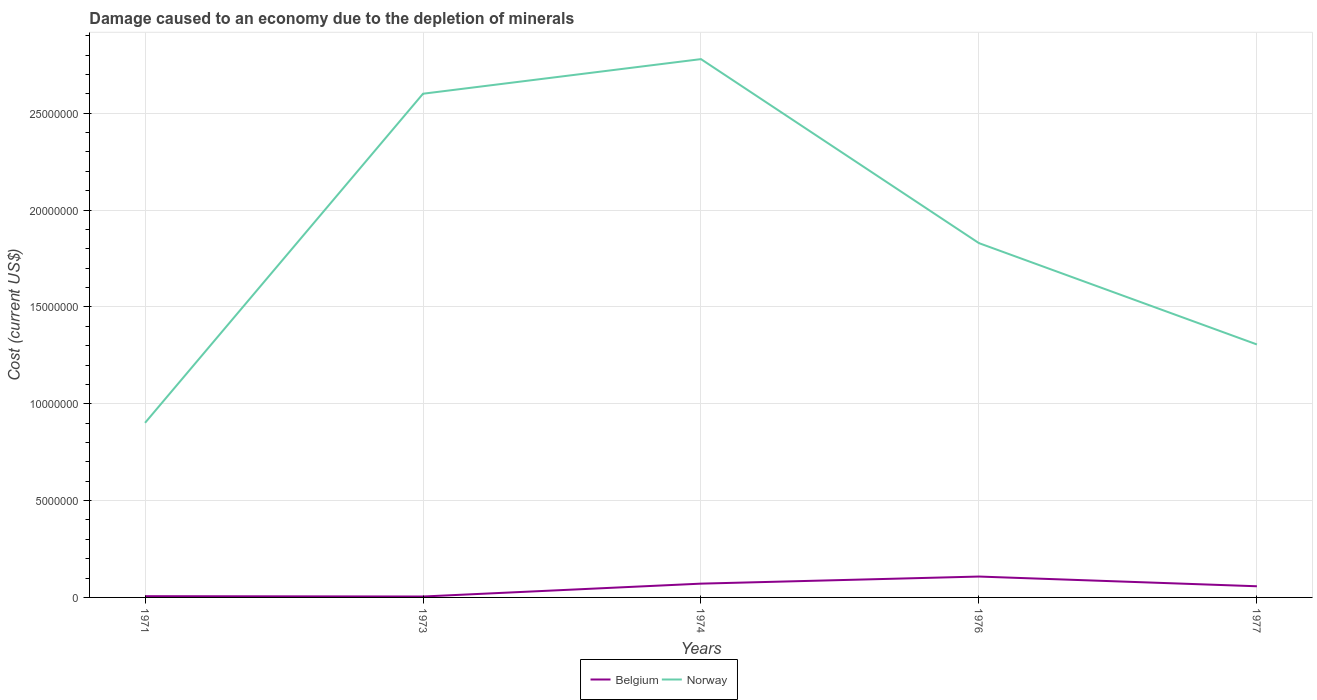How many different coloured lines are there?
Offer a very short reply. 2. Across all years, what is the maximum cost of damage caused due to the depletion of minerals in Belgium?
Ensure brevity in your answer.  4.70e+04. What is the total cost of damage caused due to the depletion of minerals in Belgium in the graph?
Keep it short and to the point. -5.29e+05. What is the difference between the highest and the second highest cost of damage caused due to the depletion of minerals in Norway?
Give a very brief answer. 1.88e+07. What is the difference between the highest and the lowest cost of damage caused due to the depletion of minerals in Belgium?
Provide a short and direct response. 3. How many years are there in the graph?
Your answer should be very brief. 5. What is the difference between two consecutive major ticks on the Y-axis?
Offer a terse response. 5.00e+06. Are the values on the major ticks of Y-axis written in scientific E-notation?
Your response must be concise. No. Does the graph contain grids?
Ensure brevity in your answer.  Yes. How are the legend labels stacked?
Offer a terse response. Horizontal. What is the title of the graph?
Make the answer very short. Damage caused to an economy due to the depletion of minerals. What is the label or title of the Y-axis?
Your response must be concise. Cost (current US$). What is the Cost (current US$) of Belgium in 1971?
Provide a short and direct response. 6.47e+04. What is the Cost (current US$) of Norway in 1971?
Your answer should be compact. 9.01e+06. What is the Cost (current US$) of Belgium in 1973?
Your response must be concise. 4.70e+04. What is the Cost (current US$) in Norway in 1973?
Provide a short and direct response. 2.60e+07. What is the Cost (current US$) in Belgium in 1974?
Provide a succinct answer. 7.12e+05. What is the Cost (current US$) in Norway in 1974?
Keep it short and to the point. 2.78e+07. What is the Cost (current US$) in Belgium in 1976?
Provide a short and direct response. 1.08e+06. What is the Cost (current US$) of Norway in 1976?
Provide a short and direct response. 1.83e+07. What is the Cost (current US$) in Belgium in 1977?
Keep it short and to the point. 5.77e+05. What is the Cost (current US$) in Norway in 1977?
Your response must be concise. 1.31e+07. Across all years, what is the maximum Cost (current US$) in Belgium?
Give a very brief answer. 1.08e+06. Across all years, what is the maximum Cost (current US$) in Norway?
Make the answer very short. 2.78e+07. Across all years, what is the minimum Cost (current US$) of Belgium?
Keep it short and to the point. 4.70e+04. Across all years, what is the minimum Cost (current US$) in Norway?
Ensure brevity in your answer.  9.01e+06. What is the total Cost (current US$) of Belgium in the graph?
Give a very brief answer. 2.48e+06. What is the total Cost (current US$) in Norway in the graph?
Give a very brief answer. 9.42e+07. What is the difference between the Cost (current US$) of Belgium in 1971 and that in 1973?
Offer a very short reply. 1.76e+04. What is the difference between the Cost (current US$) of Norway in 1971 and that in 1973?
Provide a short and direct response. -1.70e+07. What is the difference between the Cost (current US$) of Belgium in 1971 and that in 1974?
Provide a succinct answer. -6.47e+05. What is the difference between the Cost (current US$) of Norway in 1971 and that in 1974?
Your answer should be very brief. -1.88e+07. What is the difference between the Cost (current US$) in Belgium in 1971 and that in 1976?
Keep it short and to the point. -1.01e+06. What is the difference between the Cost (current US$) in Norway in 1971 and that in 1976?
Your response must be concise. -9.28e+06. What is the difference between the Cost (current US$) in Belgium in 1971 and that in 1977?
Offer a very short reply. -5.12e+05. What is the difference between the Cost (current US$) of Norway in 1971 and that in 1977?
Offer a terse response. -4.05e+06. What is the difference between the Cost (current US$) of Belgium in 1973 and that in 1974?
Provide a short and direct response. -6.65e+05. What is the difference between the Cost (current US$) of Norway in 1973 and that in 1974?
Make the answer very short. -1.79e+06. What is the difference between the Cost (current US$) of Belgium in 1973 and that in 1976?
Your response must be concise. -1.03e+06. What is the difference between the Cost (current US$) in Norway in 1973 and that in 1976?
Give a very brief answer. 7.71e+06. What is the difference between the Cost (current US$) in Belgium in 1973 and that in 1977?
Keep it short and to the point. -5.29e+05. What is the difference between the Cost (current US$) in Norway in 1973 and that in 1977?
Your response must be concise. 1.29e+07. What is the difference between the Cost (current US$) of Belgium in 1974 and that in 1976?
Your answer should be compact. -3.66e+05. What is the difference between the Cost (current US$) in Norway in 1974 and that in 1976?
Provide a succinct answer. 9.50e+06. What is the difference between the Cost (current US$) of Belgium in 1974 and that in 1977?
Offer a terse response. 1.36e+05. What is the difference between the Cost (current US$) in Norway in 1974 and that in 1977?
Your answer should be very brief. 1.47e+07. What is the difference between the Cost (current US$) in Belgium in 1976 and that in 1977?
Your answer should be compact. 5.01e+05. What is the difference between the Cost (current US$) in Norway in 1976 and that in 1977?
Your response must be concise. 5.23e+06. What is the difference between the Cost (current US$) of Belgium in 1971 and the Cost (current US$) of Norway in 1973?
Give a very brief answer. -2.59e+07. What is the difference between the Cost (current US$) in Belgium in 1971 and the Cost (current US$) in Norway in 1974?
Provide a succinct answer. -2.77e+07. What is the difference between the Cost (current US$) in Belgium in 1971 and the Cost (current US$) in Norway in 1976?
Make the answer very short. -1.82e+07. What is the difference between the Cost (current US$) of Belgium in 1971 and the Cost (current US$) of Norway in 1977?
Offer a terse response. -1.30e+07. What is the difference between the Cost (current US$) in Belgium in 1973 and the Cost (current US$) in Norway in 1974?
Provide a succinct answer. -2.77e+07. What is the difference between the Cost (current US$) of Belgium in 1973 and the Cost (current US$) of Norway in 1976?
Make the answer very short. -1.82e+07. What is the difference between the Cost (current US$) of Belgium in 1973 and the Cost (current US$) of Norway in 1977?
Your response must be concise. -1.30e+07. What is the difference between the Cost (current US$) of Belgium in 1974 and the Cost (current US$) of Norway in 1976?
Provide a succinct answer. -1.76e+07. What is the difference between the Cost (current US$) of Belgium in 1974 and the Cost (current US$) of Norway in 1977?
Give a very brief answer. -1.23e+07. What is the difference between the Cost (current US$) of Belgium in 1976 and the Cost (current US$) of Norway in 1977?
Provide a succinct answer. -1.20e+07. What is the average Cost (current US$) in Belgium per year?
Your response must be concise. 4.96e+05. What is the average Cost (current US$) of Norway per year?
Your response must be concise. 1.88e+07. In the year 1971, what is the difference between the Cost (current US$) of Belgium and Cost (current US$) of Norway?
Ensure brevity in your answer.  -8.95e+06. In the year 1973, what is the difference between the Cost (current US$) in Belgium and Cost (current US$) in Norway?
Provide a short and direct response. -2.60e+07. In the year 1974, what is the difference between the Cost (current US$) of Belgium and Cost (current US$) of Norway?
Your answer should be compact. -2.71e+07. In the year 1976, what is the difference between the Cost (current US$) in Belgium and Cost (current US$) in Norway?
Provide a short and direct response. -1.72e+07. In the year 1977, what is the difference between the Cost (current US$) of Belgium and Cost (current US$) of Norway?
Your answer should be very brief. -1.25e+07. What is the ratio of the Cost (current US$) of Belgium in 1971 to that in 1973?
Your response must be concise. 1.38. What is the ratio of the Cost (current US$) of Norway in 1971 to that in 1973?
Your answer should be very brief. 0.35. What is the ratio of the Cost (current US$) of Belgium in 1971 to that in 1974?
Keep it short and to the point. 0.09. What is the ratio of the Cost (current US$) in Norway in 1971 to that in 1974?
Provide a short and direct response. 0.32. What is the ratio of the Cost (current US$) of Belgium in 1971 to that in 1976?
Your response must be concise. 0.06. What is the ratio of the Cost (current US$) of Norway in 1971 to that in 1976?
Provide a short and direct response. 0.49. What is the ratio of the Cost (current US$) in Belgium in 1971 to that in 1977?
Your response must be concise. 0.11. What is the ratio of the Cost (current US$) of Norway in 1971 to that in 1977?
Provide a short and direct response. 0.69. What is the ratio of the Cost (current US$) in Belgium in 1973 to that in 1974?
Provide a short and direct response. 0.07. What is the ratio of the Cost (current US$) of Norway in 1973 to that in 1974?
Give a very brief answer. 0.94. What is the ratio of the Cost (current US$) of Belgium in 1973 to that in 1976?
Your answer should be very brief. 0.04. What is the ratio of the Cost (current US$) in Norway in 1973 to that in 1976?
Your answer should be compact. 1.42. What is the ratio of the Cost (current US$) in Belgium in 1973 to that in 1977?
Ensure brevity in your answer.  0.08. What is the ratio of the Cost (current US$) in Norway in 1973 to that in 1977?
Ensure brevity in your answer.  1.99. What is the ratio of the Cost (current US$) in Belgium in 1974 to that in 1976?
Your answer should be compact. 0.66. What is the ratio of the Cost (current US$) of Norway in 1974 to that in 1976?
Your answer should be very brief. 1.52. What is the ratio of the Cost (current US$) of Belgium in 1974 to that in 1977?
Offer a terse response. 1.24. What is the ratio of the Cost (current US$) of Norway in 1974 to that in 1977?
Offer a terse response. 2.13. What is the ratio of the Cost (current US$) in Belgium in 1976 to that in 1977?
Ensure brevity in your answer.  1.87. What is the ratio of the Cost (current US$) in Norway in 1976 to that in 1977?
Your answer should be very brief. 1.4. What is the difference between the highest and the second highest Cost (current US$) in Belgium?
Offer a very short reply. 3.66e+05. What is the difference between the highest and the second highest Cost (current US$) of Norway?
Offer a very short reply. 1.79e+06. What is the difference between the highest and the lowest Cost (current US$) of Belgium?
Provide a succinct answer. 1.03e+06. What is the difference between the highest and the lowest Cost (current US$) of Norway?
Make the answer very short. 1.88e+07. 